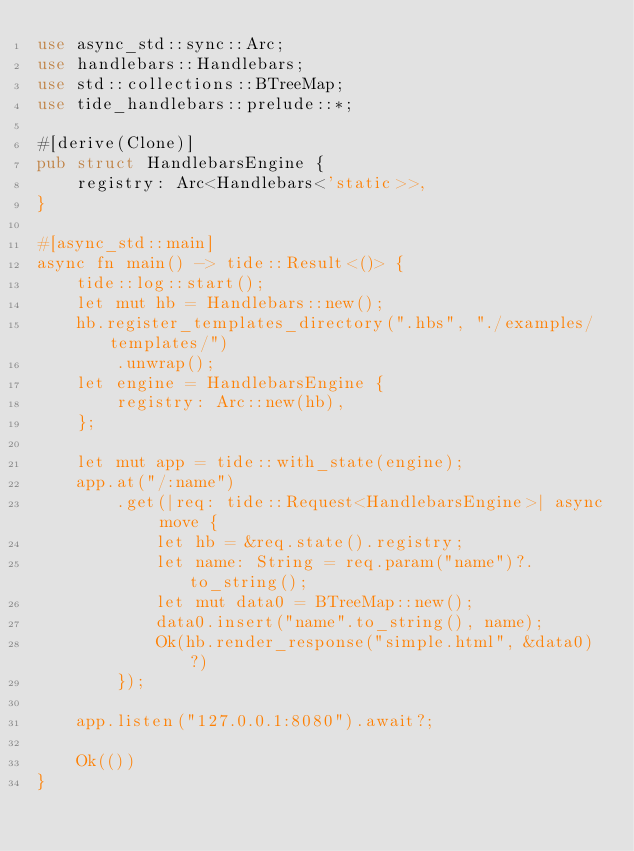Convert code to text. <code><loc_0><loc_0><loc_500><loc_500><_Rust_>use async_std::sync::Arc;
use handlebars::Handlebars;
use std::collections::BTreeMap;
use tide_handlebars::prelude::*;

#[derive(Clone)]
pub struct HandlebarsEngine {
    registry: Arc<Handlebars<'static>>,
}

#[async_std::main]
async fn main() -> tide::Result<()> {
    tide::log::start();
    let mut hb = Handlebars::new();
    hb.register_templates_directory(".hbs", "./examples/templates/")
        .unwrap();
    let engine = HandlebarsEngine {
        registry: Arc::new(hb),
    };

    let mut app = tide::with_state(engine);
    app.at("/:name")
        .get(|req: tide::Request<HandlebarsEngine>| async move {
            let hb = &req.state().registry;
            let name: String = req.param("name")?.to_string();
            let mut data0 = BTreeMap::new();
            data0.insert("name".to_string(), name);
            Ok(hb.render_response("simple.html", &data0)?)
        });

    app.listen("127.0.0.1:8080").await?;

    Ok(())
}
</code> 